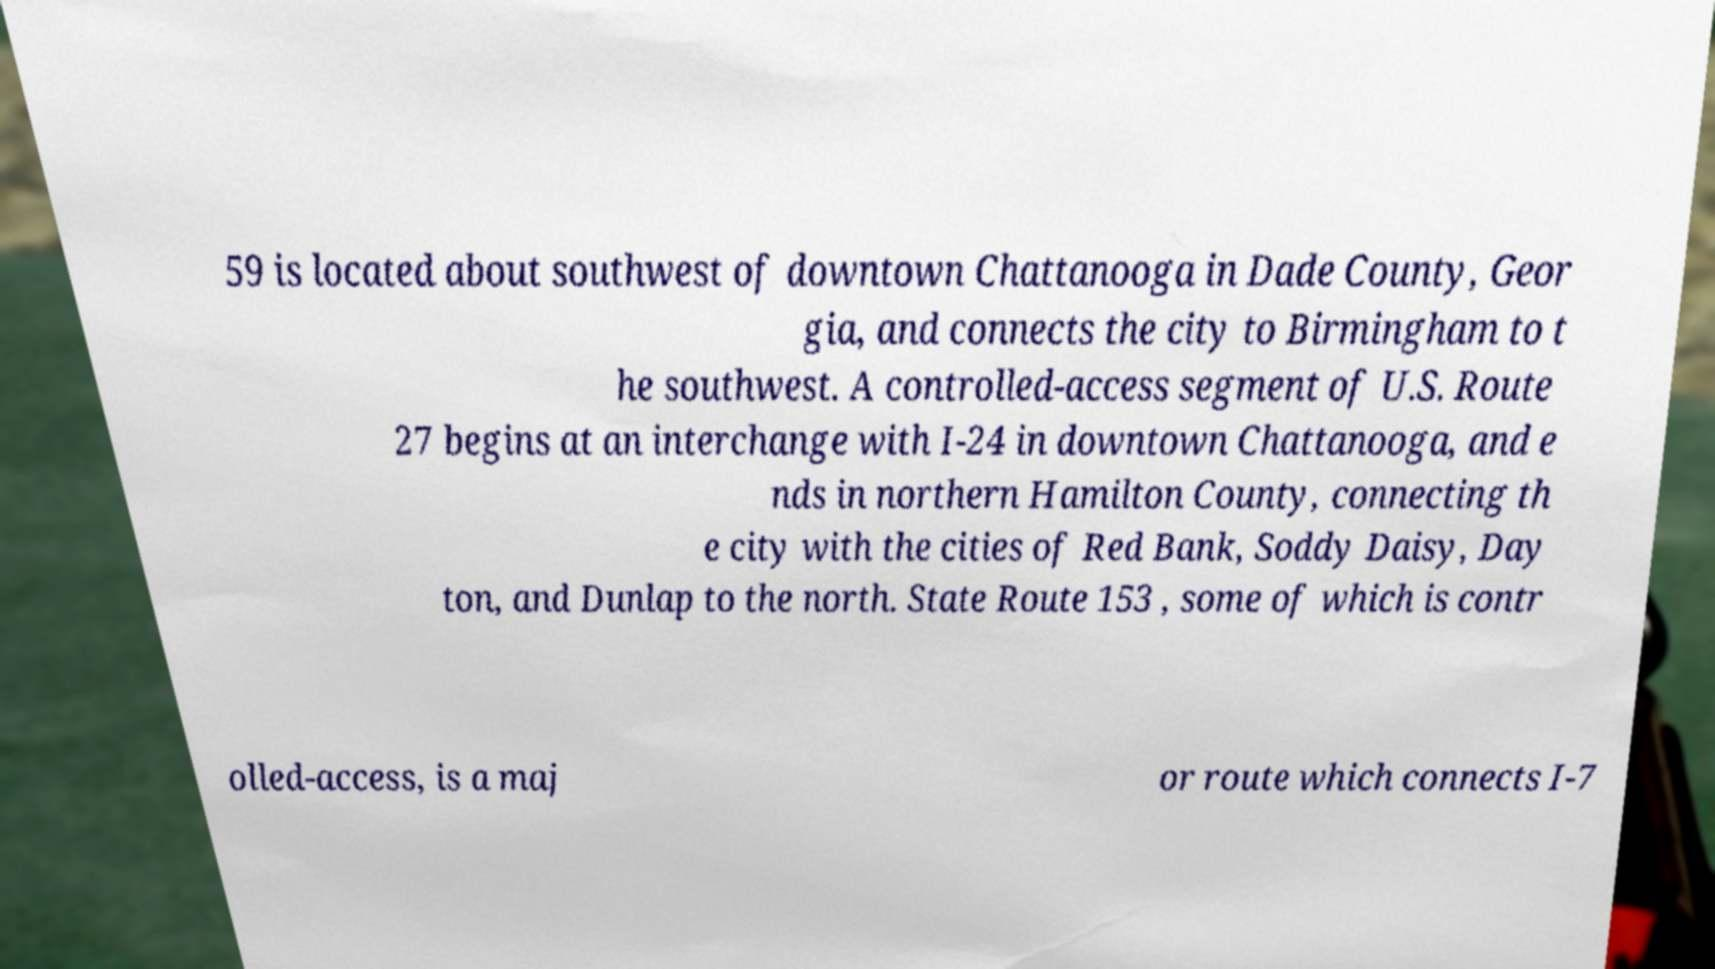Could you assist in decoding the text presented in this image and type it out clearly? 59 is located about southwest of downtown Chattanooga in Dade County, Geor gia, and connects the city to Birmingham to t he southwest. A controlled-access segment of U.S. Route 27 begins at an interchange with I-24 in downtown Chattanooga, and e nds in northern Hamilton County, connecting th e city with the cities of Red Bank, Soddy Daisy, Day ton, and Dunlap to the north. State Route 153 , some of which is contr olled-access, is a maj or route which connects I-7 